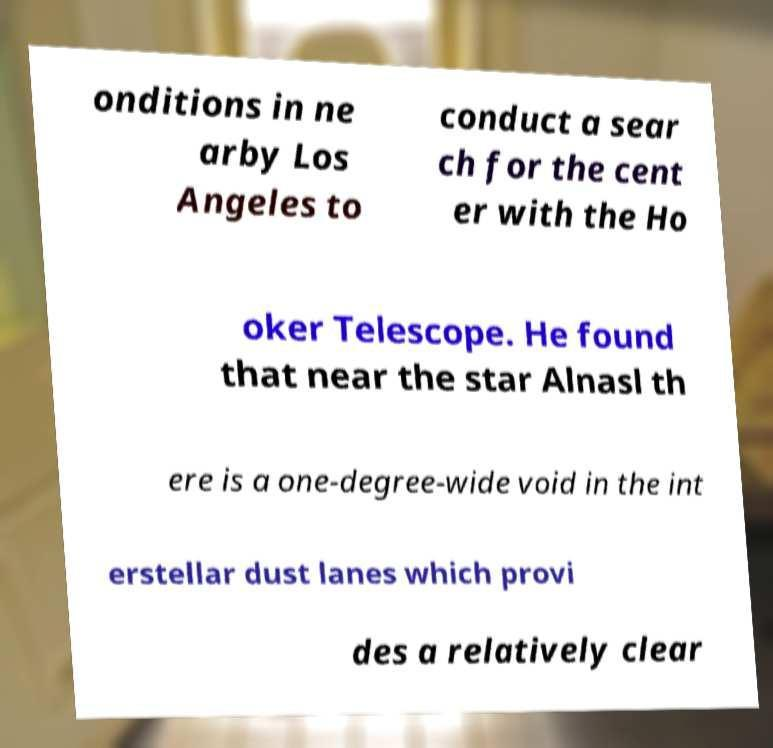What messages or text are displayed in this image? I need them in a readable, typed format. onditions in ne arby Los Angeles to conduct a sear ch for the cent er with the Ho oker Telescope. He found that near the star Alnasl th ere is a one-degree-wide void in the int erstellar dust lanes which provi des a relatively clear 